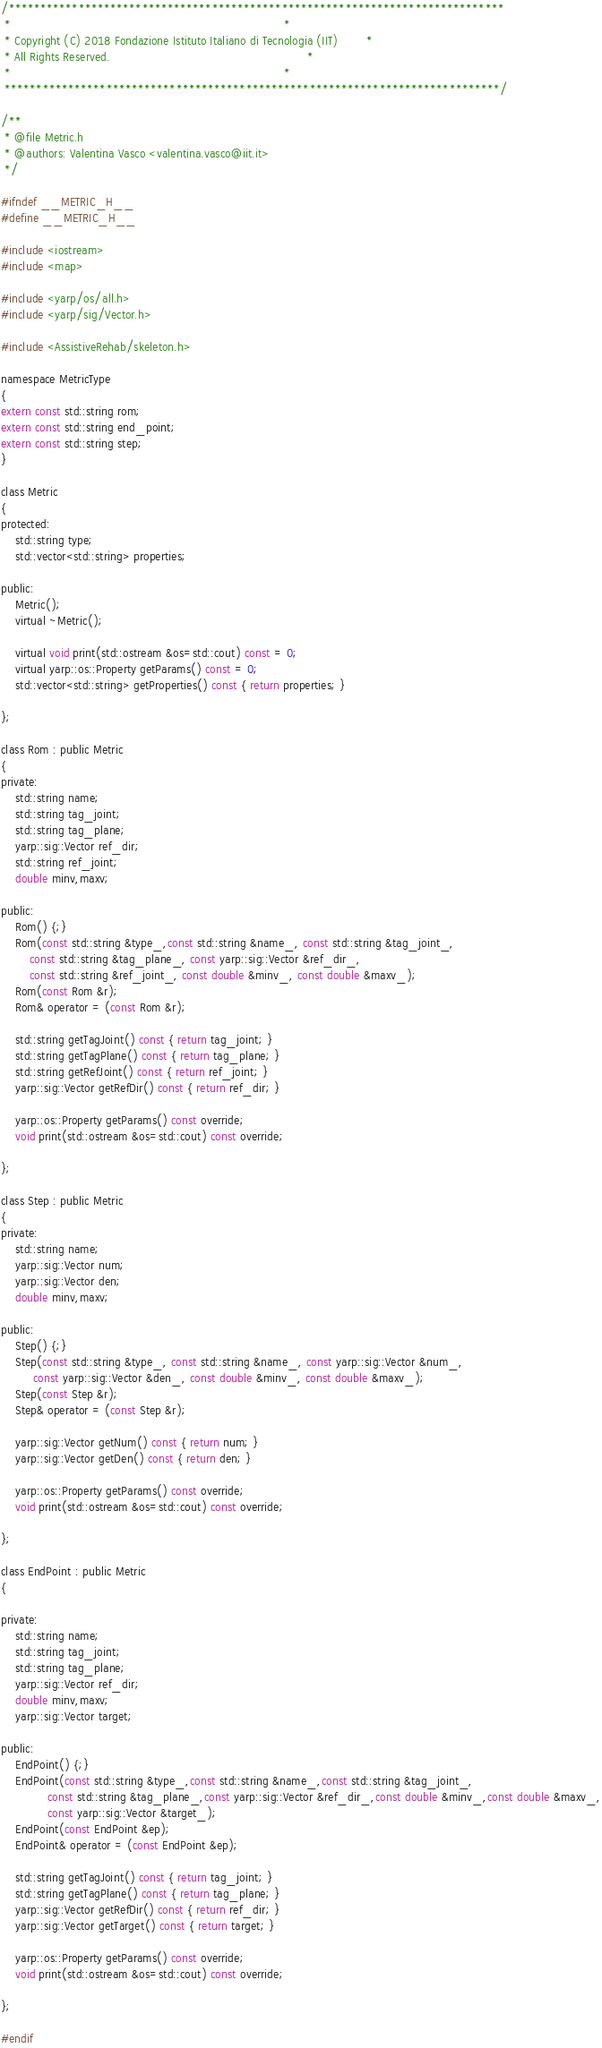Convert code to text. <code><loc_0><loc_0><loc_500><loc_500><_C_>/******************************************************************************
 *                                                                            *
 * Copyright (C) 2018 Fondazione Istituto Italiano di Tecnologia (IIT)        *
 * All Rights Reserved.                                                       *
 *                                                                            *
 ******************************************************************************/

/**
 * @file Metric.h
 * @authors: Valentina Vasco <valentina.vasco@iit.it>
 */

#ifndef __METRIC_H__
#define __METRIC_H__

#include <iostream>
#include <map>

#include <yarp/os/all.h>
#include <yarp/sig/Vector.h>

#include <AssistiveRehab/skeleton.h>

namespace MetricType
{
extern const std::string rom;
extern const std::string end_point;
extern const std::string step;
} 

class Metric
{
protected:
    std::string type;
    std::vector<std::string> properties;

public:
    Metric();
    virtual ~Metric();

    virtual void print(std::ostream &os=std::cout) const = 0;
    virtual yarp::os::Property getParams() const = 0;
    std::vector<std::string> getProperties() const { return properties; }

};

class Rom : public Metric
{
private:
    std::string name;
    std::string tag_joint;
    std::string tag_plane;
    yarp::sig::Vector ref_dir;
    std::string ref_joint;
    double minv,maxv;

public:
    Rom() {;}
    Rom(const std::string &type_,const std::string &name_, const std::string &tag_joint_,
        const std::string &tag_plane_, const yarp::sig::Vector &ref_dir_,
        const std::string &ref_joint_, const double &minv_, const double &maxv_);
    Rom(const Rom &r);
    Rom& operator = (const Rom &r);

    std::string getTagJoint() const { return tag_joint; }
    std::string getTagPlane() const { return tag_plane; }
    std::string getRefJoint() const { return ref_joint; }
    yarp::sig::Vector getRefDir() const { return ref_dir; }

    yarp::os::Property getParams() const override;
    void print(std::ostream &os=std::cout) const override;

};

class Step : public Metric
{
private:
    std::string name;
    yarp::sig::Vector num;
    yarp::sig::Vector den;
    double minv,maxv;

public:
    Step() {;}
    Step(const std::string &type_, const std::string &name_, const yarp::sig::Vector &num_,
         const yarp::sig::Vector &den_, const double &minv_, const double &maxv_);
    Step(const Step &r);
    Step& operator = (const Step &r);

    yarp::sig::Vector getNum() const { return num; }
    yarp::sig::Vector getDen() const { return den; }

    yarp::os::Property getParams() const override;
    void print(std::ostream &os=std::cout) const override;

};

class EndPoint : public Metric
{

private:
    std::string name;
    std::string tag_joint;
    std::string tag_plane;
    yarp::sig::Vector ref_dir;
    double minv,maxv;
    yarp::sig::Vector target;

public:
    EndPoint() {;}
    EndPoint(const std::string &type_,const std::string &name_,const std::string &tag_joint_,
             const std::string &tag_plane_,const yarp::sig::Vector &ref_dir_,const double &minv_,const double &maxv_,
             const yarp::sig::Vector &target_);
    EndPoint(const EndPoint &ep);
    EndPoint& operator = (const EndPoint &ep);

    std::string getTagJoint() const { return tag_joint; }
    std::string getTagPlane() const { return tag_plane; }
    yarp::sig::Vector getRefDir() const { return ref_dir; }
    yarp::sig::Vector getTarget() const { return target; }

    yarp::os::Property getParams() const override;
    void print(std::ostream &os=std::cout) const override;

};

#endif
</code> 